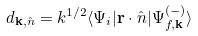Convert formula to latex. <formula><loc_0><loc_0><loc_500><loc_500>d _ { { \mathbf k } , \hat { n } } = k ^ { 1 / 2 } \langle \Psi _ { i } | { \mathbf r } \cdot \hat { n } | \Psi ^ { ( - ) } _ { f , { \mathbf k } } \rangle</formula> 